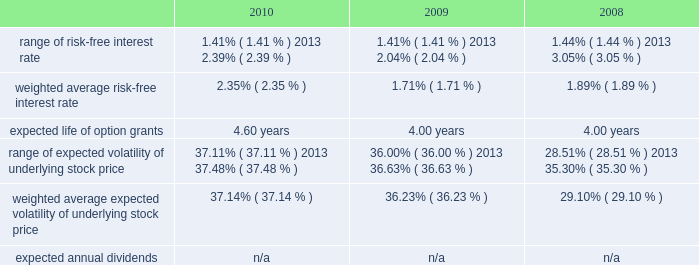American tower corporation and subsidiaries notes to consolidated financial statements assessments in each of the tax jurisdictions resulting from these examinations .
The company believes that adequate provisions have been made for income taxes for all periods through december 31 , 2010 .
12 .
Stock-based compensation the company recognized stock-based compensation of $ 52.6 million , $ 60.7 million and $ 54.8 million for the years ended december 31 , 2010 , 2009 and 2008 , respectively .
Stock-based compensation for the year ended december 31 , 2009 included $ 6.9 million related to the modification of the vesting and exercise terms for certain employee 2019s equity awards .
The company did not capitalize any stock-based compensation during the years ended december 31 , 2010 and 2009 .
Summary of stock-based compensation plans 2014the company maintains equity incentive plans that provide for the grant of stock-based awards to its directors , officers and employees .
Under the 2007 equity incentive plan ( 201c2007 plan 201d ) , which provides for the grant of non-qualified and incentive stock options , as well as restricted stock units , restricted stock and other stock-based awards , exercise prices in the case of non-qualified and incentive stock options are not less than the fair market value of the underlying common stock on the date of grant .
Equity awards typically vest ratably over various periods , generally four years , and generally expire ten years from the date of grant .
Stock options 2014as of december 31 , 2010 , the company had the ability to grant stock-based awards with respect to an aggregate of 22.0 million shares of common stock under the 2007 plan .
The fair value of each option grant is estimated on the date of grant using the black-scholes option pricing model based on the assumptions noted in the table below .
The risk-free treasury rate is based on the u.s .
Treasury yield in effect at the accounting measurement date .
The expected life ( estimated period of time outstanding ) was estimated using the vesting term and historical exercise behavior of company employees .
The expected volatility was based on historical volatility for a period equal to the expected life of the stock options .
Key assumptions used to apply this pricing model are as follows: .
The weighted average grant date fair value per share during the years ended december 31 , 2010 , 2009 and 2008 was $ 15.03 , $ 8.90 and $ 9.55 , respectively .
The intrinsic value of stock options exercised during the years ended december 31 , 2010 , 2009 and 2008 was $ 62.7 million , $ 40.1 million and $ 99.1 million , respectively .
As of december 31 , 2010 , total unrecognized compensation expense related to unvested stock options was approximately $ 27.7 million and is expected to be recognized over a weighted average period of approximately two years .
The amount of cash received from the exercise of stock options was approximately $ 129.1 million during the year ended december 31 , 2010 .
During the year ended december 31 , 2010 , the company realized approximately $ 0.3 million of state tax benefits from the exercise of stock options. .
What is the percentage change in the intrinsic value of stock options from 2007 to 2008? 
Computations: ((40.1 - 99.1) / 99.1)
Answer: -0.59536. 